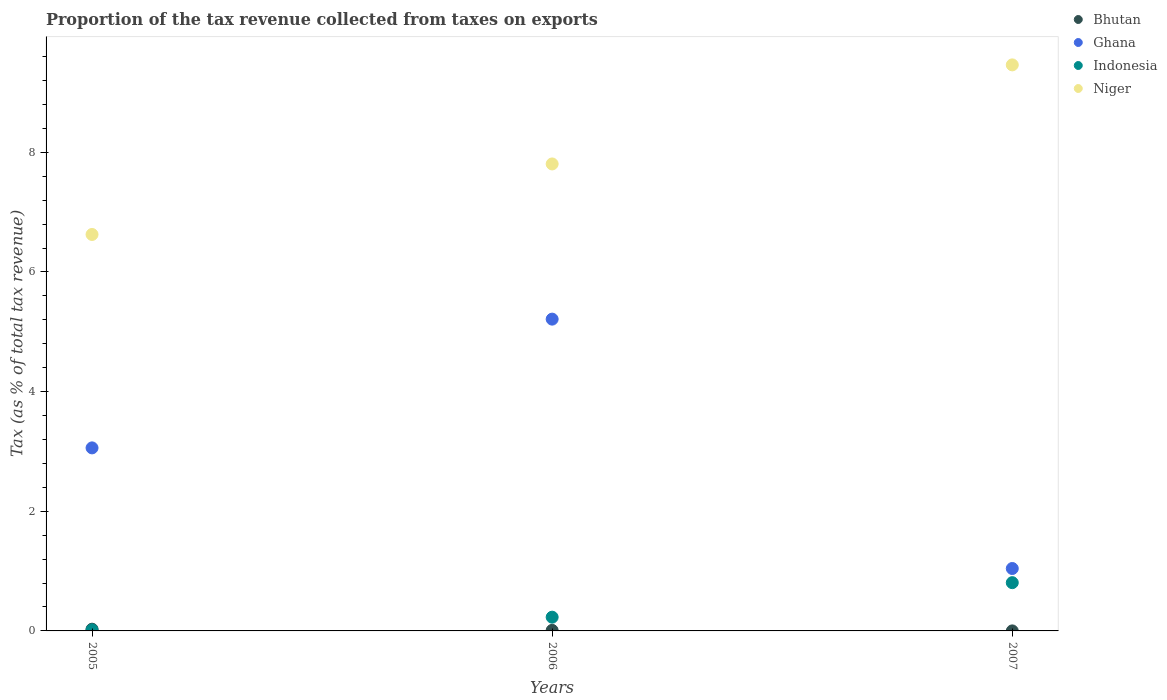How many different coloured dotlines are there?
Keep it short and to the point. 4. What is the proportion of the tax revenue collected in Bhutan in 2005?
Provide a short and direct response. 0.03. Across all years, what is the maximum proportion of the tax revenue collected in Bhutan?
Provide a short and direct response. 0.03. Across all years, what is the minimum proportion of the tax revenue collected in Indonesia?
Your response must be concise. 0.02. In which year was the proportion of the tax revenue collected in Ghana minimum?
Provide a succinct answer. 2007. What is the total proportion of the tax revenue collected in Niger in the graph?
Offer a terse response. 23.89. What is the difference between the proportion of the tax revenue collected in Bhutan in 2005 and that in 2006?
Give a very brief answer. 0.02. What is the difference between the proportion of the tax revenue collected in Bhutan in 2005 and the proportion of the tax revenue collected in Ghana in 2007?
Your answer should be very brief. -1.01. What is the average proportion of the tax revenue collected in Niger per year?
Your answer should be very brief. 7.96. In the year 2007, what is the difference between the proportion of the tax revenue collected in Niger and proportion of the tax revenue collected in Indonesia?
Ensure brevity in your answer.  8.66. What is the ratio of the proportion of the tax revenue collected in Indonesia in 2005 to that in 2007?
Offer a terse response. 0.02. Is the proportion of the tax revenue collected in Indonesia in 2005 less than that in 2007?
Provide a succinct answer. Yes. What is the difference between the highest and the second highest proportion of the tax revenue collected in Ghana?
Your response must be concise. 2.15. What is the difference between the highest and the lowest proportion of the tax revenue collected in Bhutan?
Offer a very short reply. 0.03. In how many years, is the proportion of the tax revenue collected in Bhutan greater than the average proportion of the tax revenue collected in Bhutan taken over all years?
Provide a succinct answer. 1. Is the sum of the proportion of the tax revenue collected in Ghana in 2006 and 2007 greater than the maximum proportion of the tax revenue collected in Indonesia across all years?
Ensure brevity in your answer.  Yes. Is it the case that in every year, the sum of the proportion of the tax revenue collected in Ghana and proportion of the tax revenue collected in Bhutan  is greater than the proportion of the tax revenue collected in Niger?
Ensure brevity in your answer.  No. Does the proportion of the tax revenue collected in Bhutan monotonically increase over the years?
Offer a very short reply. No. Is the proportion of the tax revenue collected in Indonesia strictly less than the proportion of the tax revenue collected in Ghana over the years?
Your answer should be very brief. Yes. How many dotlines are there?
Make the answer very short. 4. How many years are there in the graph?
Make the answer very short. 3. Are the values on the major ticks of Y-axis written in scientific E-notation?
Make the answer very short. No. Does the graph contain any zero values?
Give a very brief answer. No. Does the graph contain grids?
Ensure brevity in your answer.  No. Where does the legend appear in the graph?
Provide a short and direct response. Top right. How are the legend labels stacked?
Keep it short and to the point. Vertical. What is the title of the graph?
Provide a succinct answer. Proportion of the tax revenue collected from taxes on exports. What is the label or title of the X-axis?
Your answer should be compact. Years. What is the label or title of the Y-axis?
Provide a succinct answer. Tax (as % of total tax revenue). What is the Tax (as % of total tax revenue) of Bhutan in 2005?
Make the answer very short. 0.03. What is the Tax (as % of total tax revenue) of Ghana in 2005?
Keep it short and to the point. 3.06. What is the Tax (as % of total tax revenue) of Indonesia in 2005?
Your answer should be compact. 0.02. What is the Tax (as % of total tax revenue) in Niger in 2005?
Ensure brevity in your answer.  6.63. What is the Tax (as % of total tax revenue) of Bhutan in 2006?
Provide a short and direct response. 0.01. What is the Tax (as % of total tax revenue) of Ghana in 2006?
Offer a terse response. 5.21. What is the Tax (as % of total tax revenue) of Indonesia in 2006?
Your answer should be very brief. 0.23. What is the Tax (as % of total tax revenue) in Niger in 2006?
Provide a succinct answer. 7.81. What is the Tax (as % of total tax revenue) in Bhutan in 2007?
Your response must be concise. 0. What is the Tax (as % of total tax revenue) in Ghana in 2007?
Keep it short and to the point. 1.04. What is the Tax (as % of total tax revenue) in Indonesia in 2007?
Keep it short and to the point. 0.81. What is the Tax (as % of total tax revenue) in Niger in 2007?
Your answer should be compact. 9.46. Across all years, what is the maximum Tax (as % of total tax revenue) in Bhutan?
Your answer should be compact. 0.03. Across all years, what is the maximum Tax (as % of total tax revenue) in Ghana?
Your answer should be very brief. 5.21. Across all years, what is the maximum Tax (as % of total tax revenue) in Indonesia?
Your answer should be compact. 0.81. Across all years, what is the maximum Tax (as % of total tax revenue) in Niger?
Your response must be concise. 9.46. Across all years, what is the minimum Tax (as % of total tax revenue) of Bhutan?
Provide a succinct answer. 0. Across all years, what is the minimum Tax (as % of total tax revenue) of Ghana?
Ensure brevity in your answer.  1.04. Across all years, what is the minimum Tax (as % of total tax revenue) of Indonesia?
Offer a very short reply. 0.02. Across all years, what is the minimum Tax (as % of total tax revenue) of Niger?
Offer a very short reply. 6.63. What is the total Tax (as % of total tax revenue) of Bhutan in the graph?
Provide a short and direct response. 0.04. What is the total Tax (as % of total tax revenue) of Ghana in the graph?
Make the answer very short. 9.31. What is the total Tax (as % of total tax revenue) in Indonesia in the graph?
Keep it short and to the point. 1.05. What is the total Tax (as % of total tax revenue) in Niger in the graph?
Your answer should be very brief. 23.89. What is the difference between the Tax (as % of total tax revenue) of Bhutan in 2005 and that in 2006?
Your answer should be compact. 0.02. What is the difference between the Tax (as % of total tax revenue) in Ghana in 2005 and that in 2006?
Offer a very short reply. -2.15. What is the difference between the Tax (as % of total tax revenue) of Indonesia in 2005 and that in 2006?
Your response must be concise. -0.21. What is the difference between the Tax (as % of total tax revenue) of Niger in 2005 and that in 2006?
Ensure brevity in your answer.  -1.18. What is the difference between the Tax (as % of total tax revenue) of Bhutan in 2005 and that in 2007?
Give a very brief answer. 0.03. What is the difference between the Tax (as % of total tax revenue) in Ghana in 2005 and that in 2007?
Offer a terse response. 2.02. What is the difference between the Tax (as % of total tax revenue) of Indonesia in 2005 and that in 2007?
Give a very brief answer. -0.79. What is the difference between the Tax (as % of total tax revenue) in Niger in 2005 and that in 2007?
Your answer should be very brief. -2.83. What is the difference between the Tax (as % of total tax revenue) of Bhutan in 2006 and that in 2007?
Your answer should be very brief. 0.01. What is the difference between the Tax (as % of total tax revenue) of Ghana in 2006 and that in 2007?
Your answer should be compact. 4.17. What is the difference between the Tax (as % of total tax revenue) in Indonesia in 2006 and that in 2007?
Your answer should be very brief. -0.58. What is the difference between the Tax (as % of total tax revenue) in Niger in 2006 and that in 2007?
Ensure brevity in your answer.  -1.66. What is the difference between the Tax (as % of total tax revenue) of Bhutan in 2005 and the Tax (as % of total tax revenue) of Ghana in 2006?
Give a very brief answer. -5.18. What is the difference between the Tax (as % of total tax revenue) of Bhutan in 2005 and the Tax (as % of total tax revenue) of Indonesia in 2006?
Keep it short and to the point. -0.2. What is the difference between the Tax (as % of total tax revenue) in Bhutan in 2005 and the Tax (as % of total tax revenue) in Niger in 2006?
Make the answer very short. -7.78. What is the difference between the Tax (as % of total tax revenue) of Ghana in 2005 and the Tax (as % of total tax revenue) of Indonesia in 2006?
Give a very brief answer. 2.83. What is the difference between the Tax (as % of total tax revenue) of Ghana in 2005 and the Tax (as % of total tax revenue) of Niger in 2006?
Your answer should be very brief. -4.75. What is the difference between the Tax (as % of total tax revenue) in Indonesia in 2005 and the Tax (as % of total tax revenue) in Niger in 2006?
Ensure brevity in your answer.  -7.79. What is the difference between the Tax (as % of total tax revenue) in Bhutan in 2005 and the Tax (as % of total tax revenue) in Ghana in 2007?
Provide a short and direct response. -1.01. What is the difference between the Tax (as % of total tax revenue) in Bhutan in 2005 and the Tax (as % of total tax revenue) in Indonesia in 2007?
Make the answer very short. -0.78. What is the difference between the Tax (as % of total tax revenue) of Bhutan in 2005 and the Tax (as % of total tax revenue) of Niger in 2007?
Offer a very short reply. -9.43. What is the difference between the Tax (as % of total tax revenue) in Ghana in 2005 and the Tax (as % of total tax revenue) in Indonesia in 2007?
Keep it short and to the point. 2.25. What is the difference between the Tax (as % of total tax revenue) in Ghana in 2005 and the Tax (as % of total tax revenue) in Niger in 2007?
Your response must be concise. -6.4. What is the difference between the Tax (as % of total tax revenue) in Indonesia in 2005 and the Tax (as % of total tax revenue) in Niger in 2007?
Provide a short and direct response. -9.44. What is the difference between the Tax (as % of total tax revenue) of Bhutan in 2006 and the Tax (as % of total tax revenue) of Ghana in 2007?
Provide a succinct answer. -1.03. What is the difference between the Tax (as % of total tax revenue) in Bhutan in 2006 and the Tax (as % of total tax revenue) in Indonesia in 2007?
Provide a short and direct response. -0.8. What is the difference between the Tax (as % of total tax revenue) of Bhutan in 2006 and the Tax (as % of total tax revenue) of Niger in 2007?
Offer a very short reply. -9.45. What is the difference between the Tax (as % of total tax revenue) of Ghana in 2006 and the Tax (as % of total tax revenue) of Indonesia in 2007?
Your response must be concise. 4.41. What is the difference between the Tax (as % of total tax revenue) of Ghana in 2006 and the Tax (as % of total tax revenue) of Niger in 2007?
Ensure brevity in your answer.  -4.25. What is the difference between the Tax (as % of total tax revenue) in Indonesia in 2006 and the Tax (as % of total tax revenue) in Niger in 2007?
Offer a terse response. -9.23. What is the average Tax (as % of total tax revenue) in Bhutan per year?
Provide a short and direct response. 0.01. What is the average Tax (as % of total tax revenue) of Ghana per year?
Your response must be concise. 3.1. What is the average Tax (as % of total tax revenue) of Indonesia per year?
Offer a very short reply. 0.35. What is the average Tax (as % of total tax revenue) in Niger per year?
Your answer should be compact. 7.96. In the year 2005, what is the difference between the Tax (as % of total tax revenue) in Bhutan and Tax (as % of total tax revenue) in Ghana?
Your answer should be very brief. -3.03. In the year 2005, what is the difference between the Tax (as % of total tax revenue) of Bhutan and Tax (as % of total tax revenue) of Indonesia?
Offer a very short reply. 0.01. In the year 2005, what is the difference between the Tax (as % of total tax revenue) of Bhutan and Tax (as % of total tax revenue) of Niger?
Your answer should be compact. -6.6. In the year 2005, what is the difference between the Tax (as % of total tax revenue) in Ghana and Tax (as % of total tax revenue) in Indonesia?
Keep it short and to the point. 3.04. In the year 2005, what is the difference between the Tax (as % of total tax revenue) in Ghana and Tax (as % of total tax revenue) in Niger?
Keep it short and to the point. -3.57. In the year 2005, what is the difference between the Tax (as % of total tax revenue) of Indonesia and Tax (as % of total tax revenue) of Niger?
Provide a short and direct response. -6.61. In the year 2006, what is the difference between the Tax (as % of total tax revenue) of Bhutan and Tax (as % of total tax revenue) of Ghana?
Your response must be concise. -5.2. In the year 2006, what is the difference between the Tax (as % of total tax revenue) in Bhutan and Tax (as % of total tax revenue) in Indonesia?
Give a very brief answer. -0.22. In the year 2006, what is the difference between the Tax (as % of total tax revenue) of Bhutan and Tax (as % of total tax revenue) of Niger?
Offer a terse response. -7.8. In the year 2006, what is the difference between the Tax (as % of total tax revenue) of Ghana and Tax (as % of total tax revenue) of Indonesia?
Provide a succinct answer. 4.98. In the year 2006, what is the difference between the Tax (as % of total tax revenue) of Ghana and Tax (as % of total tax revenue) of Niger?
Make the answer very short. -2.59. In the year 2006, what is the difference between the Tax (as % of total tax revenue) of Indonesia and Tax (as % of total tax revenue) of Niger?
Ensure brevity in your answer.  -7.58. In the year 2007, what is the difference between the Tax (as % of total tax revenue) of Bhutan and Tax (as % of total tax revenue) of Ghana?
Provide a succinct answer. -1.04. In the year 2007, what is the difference between the Tax (as % of total tax revenue) in Bhutan and Tax (as % of total tax revenue) in Indonesia?
Ensure brevity in your answer.  -0.81. In the year 2007, what is the difference between the Tax (as % of total tax revenue) in Bhutan and Tax (as % of total tax revenue) in Niger?
Your answer should be compact. -9.46. In the year 2007, what is the difference between the Tax (as % of total tax revenue) of Ghana and Tax (as % of total tax revenue) of Indonesia?
Provide a short and direct response. 0.24. In the year 2007, what is the difference between the Tax (as % of total tax revenue) of Ghana and Tax (as % of total tax revenue) of Niger?
Make the answer very short. -8.42. In the year 2007, what is the difference between the Tax (as % of total tax revenue) in Indonesia and Tax (as % of total tax revenue) in Niger?
Give a very brief answer. -8.66. What is the ratio of the Tax (as % of total tax revenue) of Bhutan in 2005 to that in 2006?
Give a very brief answer. 3.13. What is the ratio of the Tax (as % of total tax revenue) of Ghana in 2005 to that in 2006?
Your response must be concise. 0.59. What is the ratio of the Tax (as % of total tax revenue) of Indonesia in 2005 to that in 2006?
Your answer should be compact. 0.08. What is the ratio of the Tax (as % of total tax revenue) in Niger in 2005 to that in 2006?
Provide a succinct answer. 0.85. What is the ratio of the Tax (as % of total tax revenue) of Bhutan in 2005 to that in 2007?
Ensure brevity in your answer.  89.45. What is the ratio of the Tax (as % of total tax revenue) in Ghana in 2005 to that in 2007?
Your answer should be compact. 2.93. What is the ratio of the Tax (as % of total tax revenue) in Indonesia in 2005 to that in 2007?
Provide a short and direct response. 0.02. What is the ratio of the Tax (as % of total tax revenue) in Niger in 2005 to that in 2007?
Ensure brevity in your answer.  0.7. What is the ratio of the Tax (as % of total tax revenue) of Bhutan in 2006 to that in 2007?
Offer a terse response. 28.6. What is the ratio of the Tax (as % of total tax revenue) of Ghana in 2006 to that in 2007?
Your response must be concise. 5. What is the ratio of the Tax (as % of total tax revenue) of Indonesia in 2006 to that in 2007?
Keep it short and to the point. 0.28. What is the ratio of the Tax (as % of total tax revenue) of Niger in 2006 to that in 2007?
Ensure brevity in your answer.  0.82. What is the difference between the highest and the second highest Tax (as % of total tax revenue) in Bhutan?
Your answer should be very brief. 0.02. What is the difference between the highest and the second highest Tax (as % of total tax revenue) in Ghana?
Ensure brevity in your answer.  2.15. What is the difference between the highest and the second highest Tax (as % of total tax revenue) in Indonesia?
Provide a succinct answer. 0.58. What is the difference between the highest and the second highest Tax (as % of total tax revenue) of Niger?
Your answer should be compact. 1.66. What is the difference between the highest and the lowest Tax (as % of total tax revenue) of Bhutan?
Offer a very short reply. 0.03. What is the difference between the highest and the lowest Tax (as % of total tax revenue) of Ghana?
Keep it short and to the point. 4.17. What is the difference between the highest and the lowest Tax (as % of total tax revenue) of Indonesia?
Offer a very short reply. 0.79. What is the difference between the highest and the lowest Tax (as % of total tax revenue) of Niger?
Offer a very short reply. 2.83. 